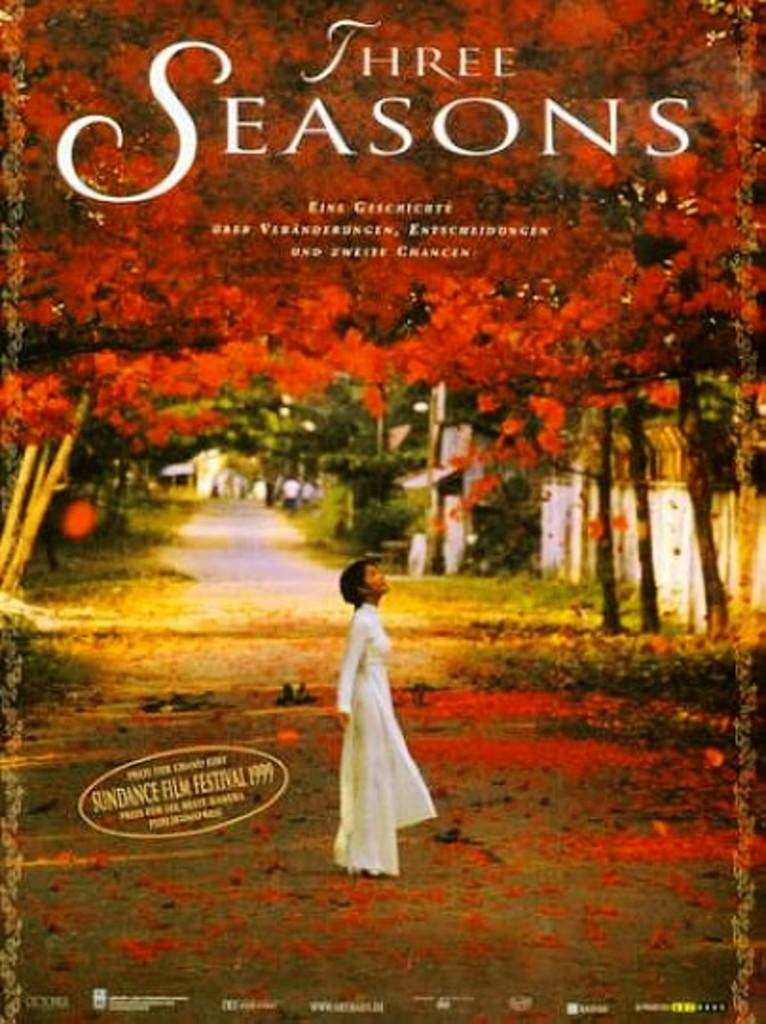<image>
Render a clear and concise summary of the photo. Teh poster for Three Seasons has a child looking at red leaves 